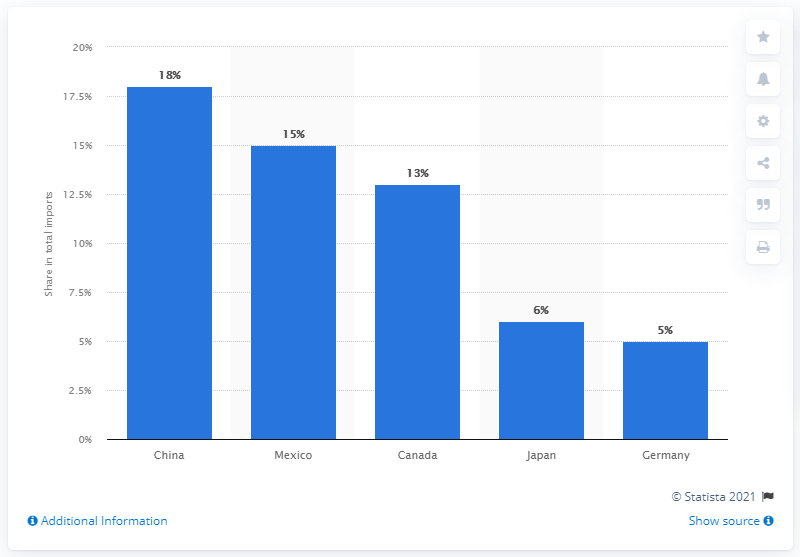Indicate a few pertinent items in this graphic. In 2019, China was the main import partner of the United States. 